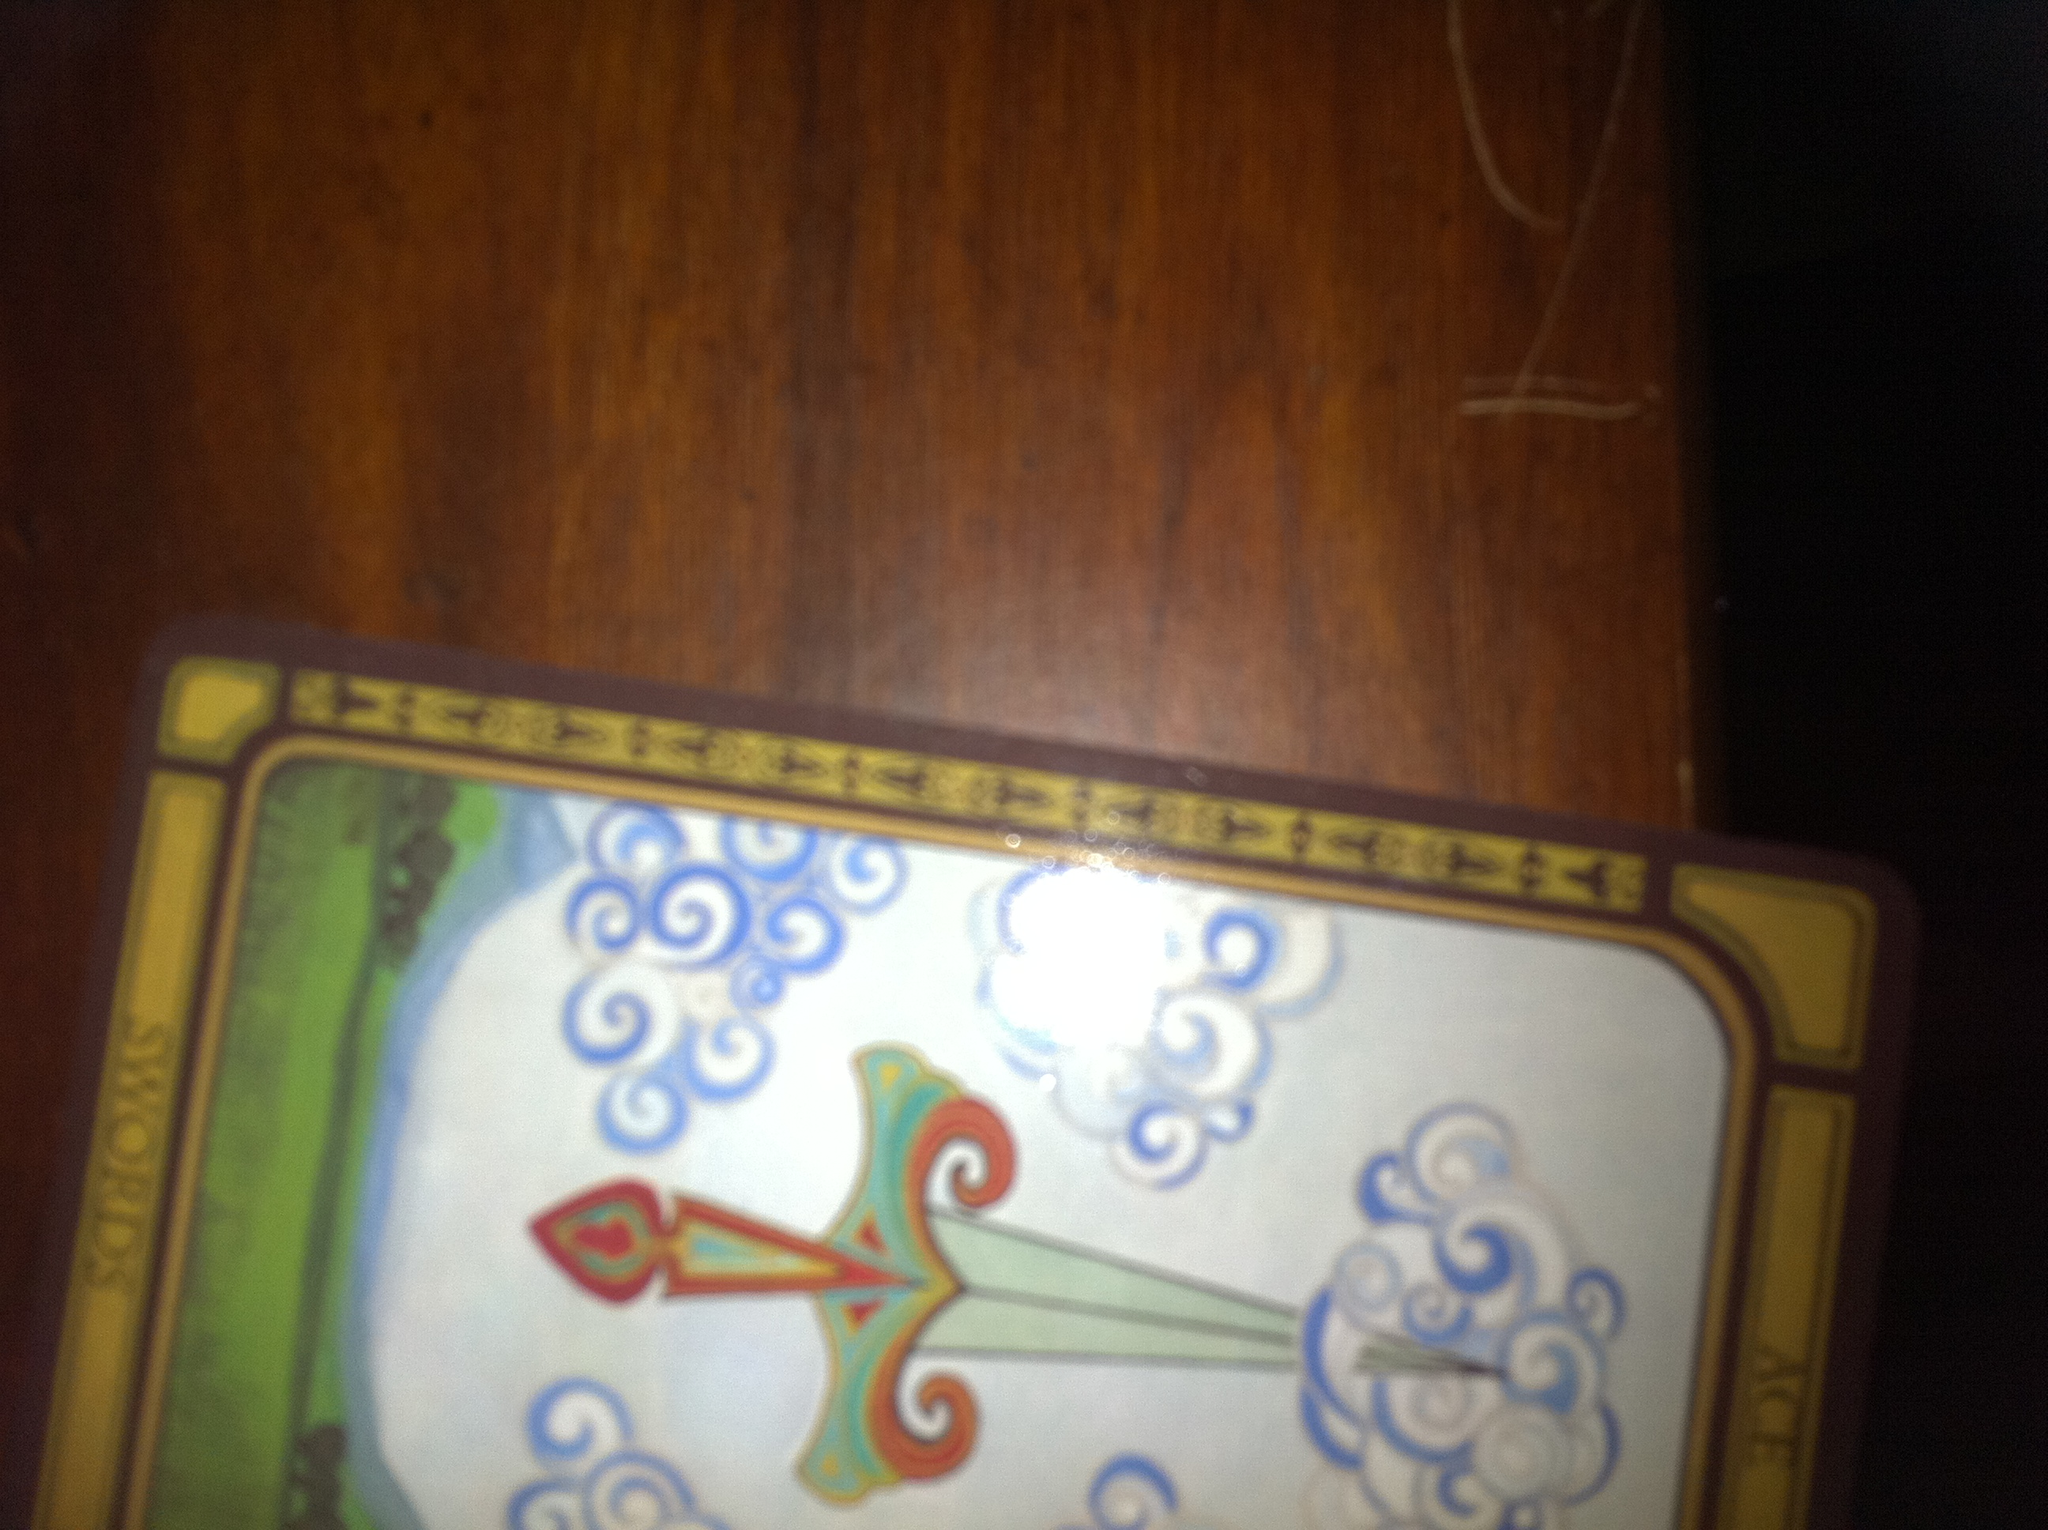Describe a very creative, imaginative backstory for this card. In a mystical realm where thoughts and ideas manifest as tangible objects, the Ace of Swords was forged by the eternal winds of wisdom. The sword's blade was created from the whispers of ancient scholars and philosophers, its hilt adorned with precious stones that hold the essence of clarity and enlightenment. Legend has it that only the chosen one, with the purest of intentions and sharpest of minds, could wield the Ace of Swords to clear the mists of ignorance that engulfed the land. This chosen hero would emerge to challenge the forces of deception, using the sword's unparalleled power to reveal truths and lead the kingdom into a new era of understanding and transparency. 